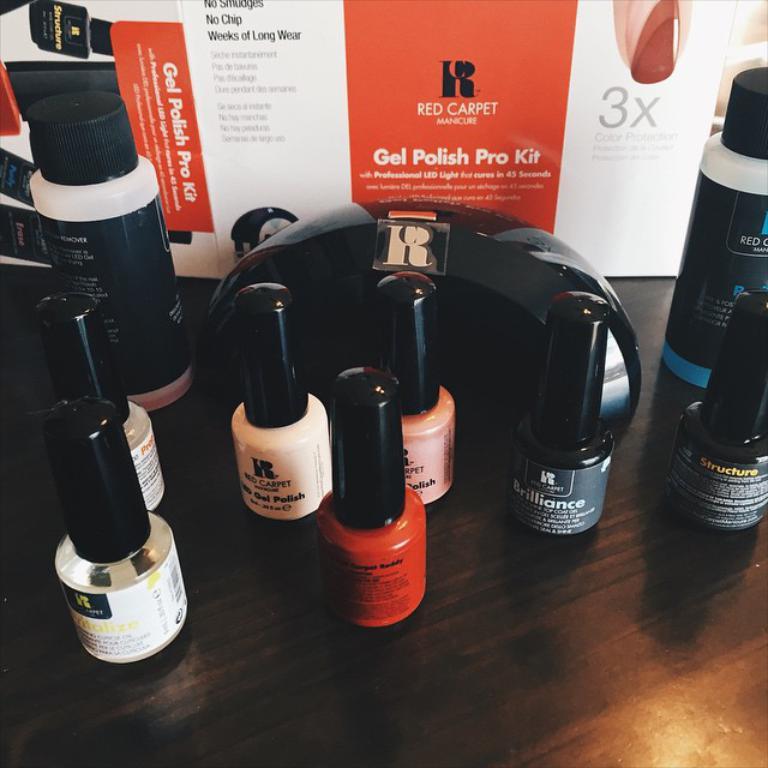What is the name of the package containing all of these bottles of nail polish?
Your response must be concise. Red carpet. What type of nailpolish is this?
Offer a terse response. Red carpet. 